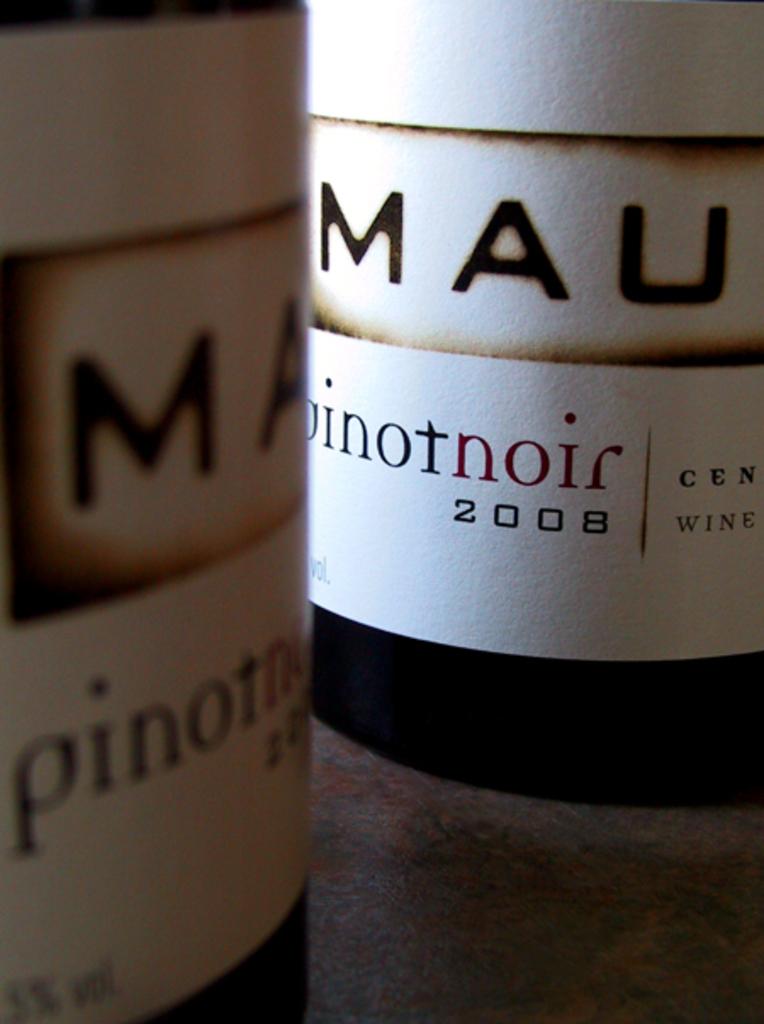What kind of wine is this?
Offer a very short reply. Pinot noir. What year is the wine?
Give a very brief answer. 2008. 